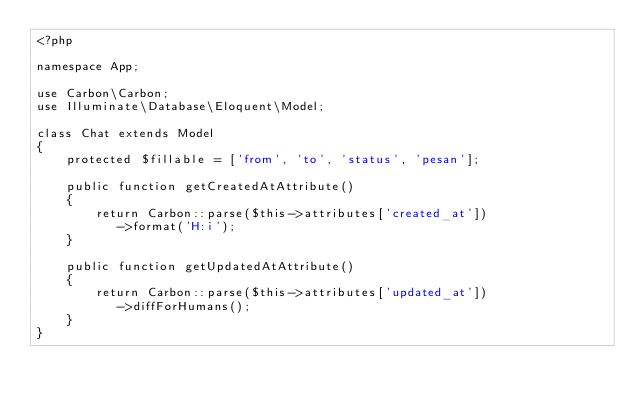<code> <loc_0><loc_0><loc_500><loc_500><_PHP_><?php

namespace App;

use Carbon\Carbon;
use Illuminate\Database\Eloquent\Model;

class Chat extends Model
{
    protected $fillable = ['from', 'to', 'status', 'pesan'];

    public function getCreatedAtAttribute()
    {
        return Carbon::parse($this->attributes['created_at'])
           ->format('H:i');
    }
    
    public function getUpdatedAtAttribute()
    {
        return Carbon::parse($this->attributes['updated_at'])
           ->diffForHumans();
    }
}
</code> 